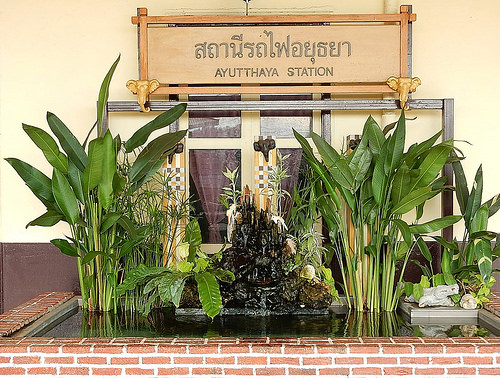<image>
Can you confirm if the plants is next to the water? Yes. The plants is positioned adjacent to the water, located nearby in the same general area. 